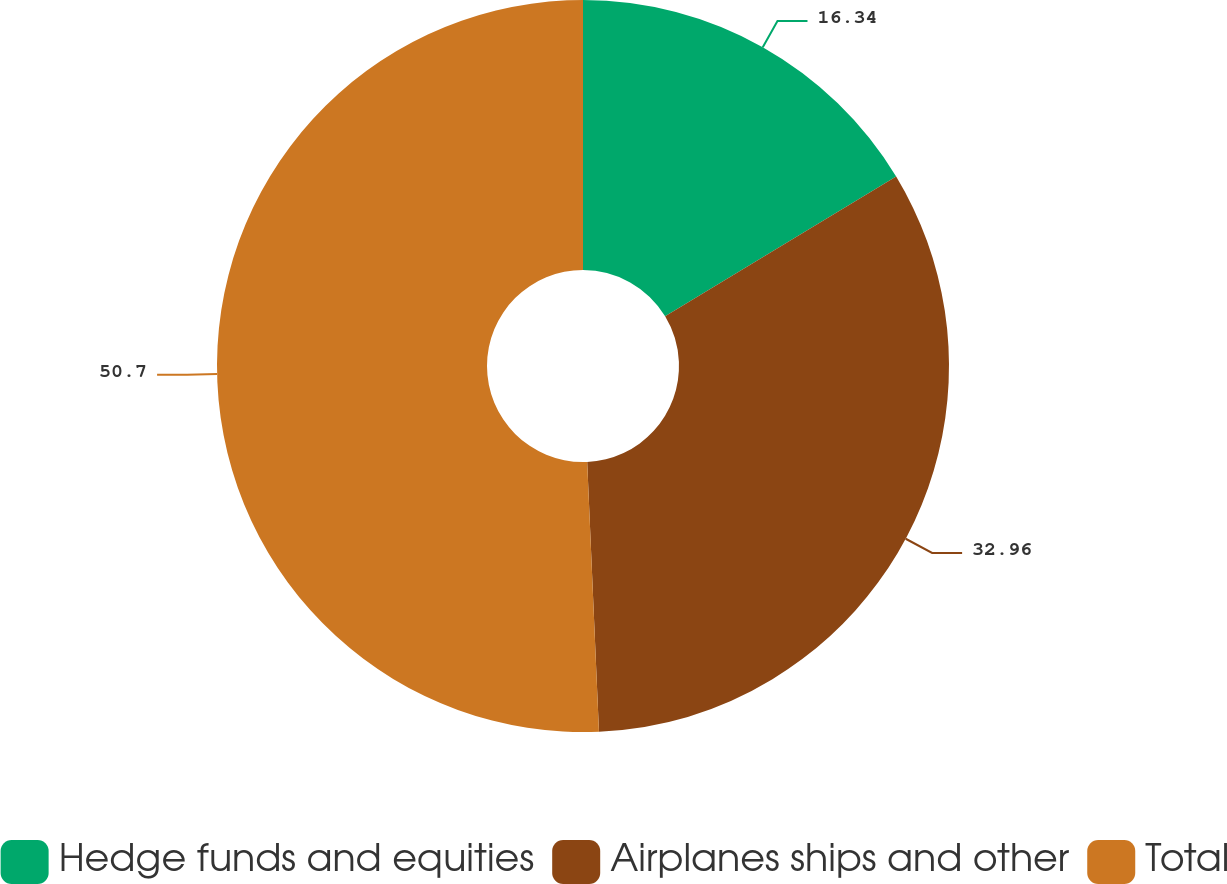Convert chart to OTSL. <chart><loc_0><loc_0><loc_500><loc_500><pie_chart><fcel>Hedge funds and equities<fcel>Airplanes ships and other<fcel>Total<nl><fcel>16.34%<fcel>32.96%<fcel>50.69%<nl></chart> 